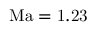Convert formula to latex. <formula><loc_0><loc_0><loc_500><loc_500>{ M a } = 1 . 2 3</formula> 